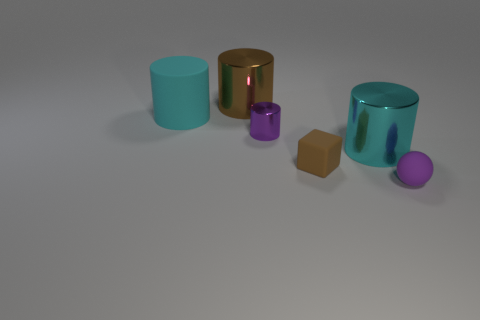Subtract all gray balls. Subtract all yellow blocks. How many balls are left? 1 Add 3 brown metallic things. How many objects exist? 9 Subtract all cubes. How many objects are left? 5 Subtract 0 yellow cubes. How many objects are left? 6 Subtract all cyan rubber cubes. Subtract all tiny rubber things. How many objects are left? 4 Add 4 tiny purple objects. How many tiny purple objects are left? 6 Add 3 purple shiny things. How many purple shiny things exist? 4 